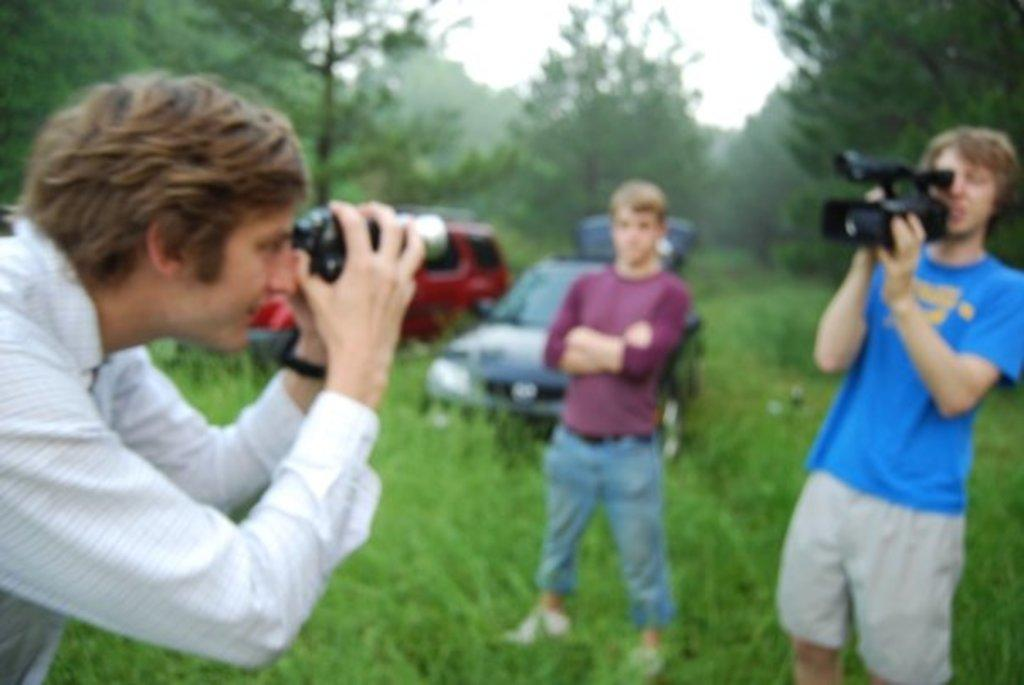How many people are in the image? There are three persons in the image. What are two of the persons doing in the image? Two of the persons are holding cameras. What is the ground made of in the image? There is grass on the ground in the image. What can be seen in the background of the image? There are vehicles and trees in the image. How many cats are playing with a whistle in the image? There are no cats or whistles present in the image. 